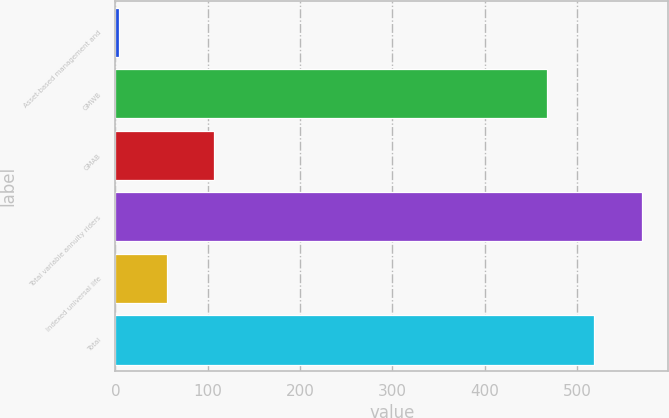<chart> <loc_0><loc_0><loc_500><loc_500><bar_chart><fcel>Asset-based management and<fcel>GMWB<fcel>GMAB<fcel>Total variable annuity riders<fcel>Indexed universal life<fcel>Total<nl><fcel>4<fcel>467<fcel>106.8<fcel>569.8<fcel>55.4<fcel>518.4<nl></chart> 